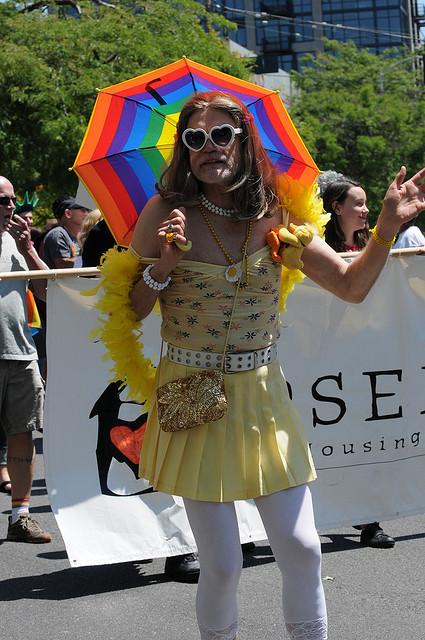What does the man use the umbrella for? Please explain your reasoning. shade. The day is very sunny, so having some shade to keep cool and keep from getting sunburned. 